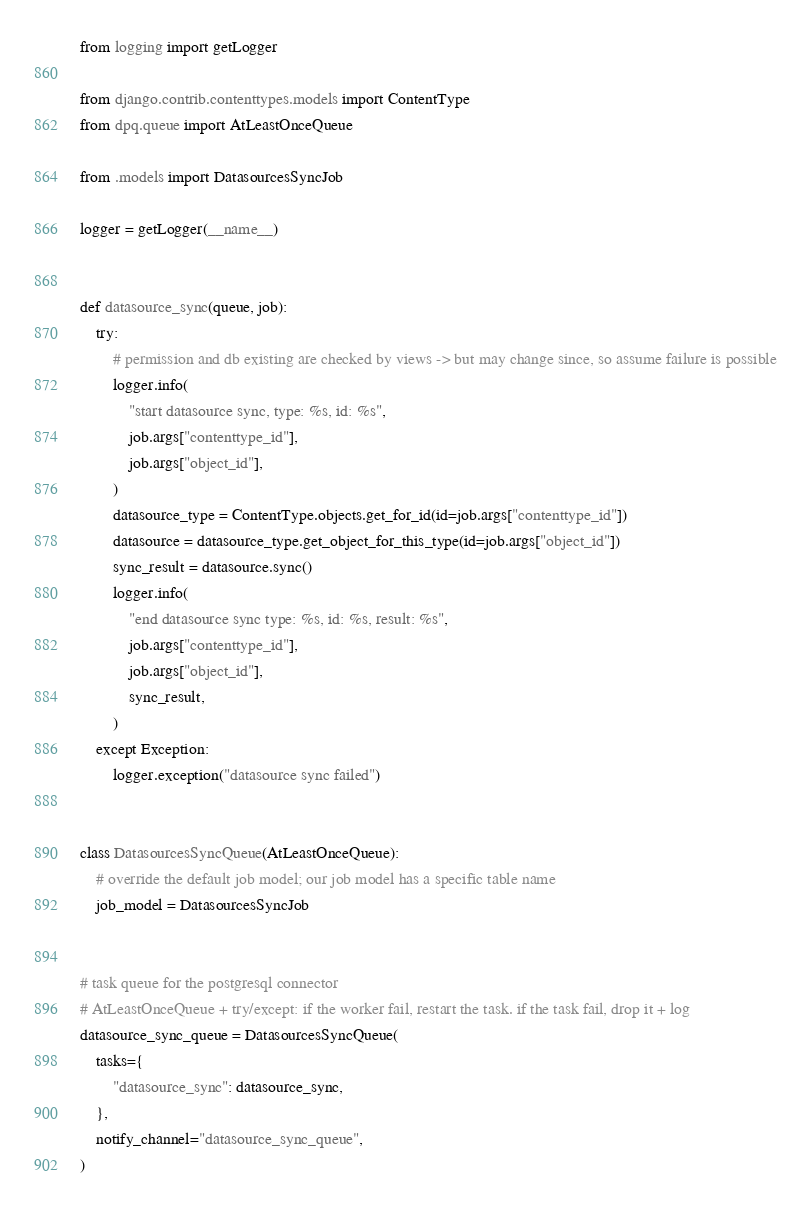<code> <loc_0><loc_0><loc_500><loc_500><_Python_>from logging import getLogger

from django.contrib.contenttypes.models import ContentType
from dpq.queue import AtLeastOnceQueue

from .models import DatasourcesSyncJob

logger = getLogger(__name__)


def datasource_sync(queue, job):
    try:
        # permission and db existing are checked by views -> but may change since, so assume failure is possible
        logger.info(
            "start datasource sync, type: %s, id: %s",
            job.args["contenttype_id"],
            job.args["object_id"],
        )
        datasource_type = ContentType.objects.get_for_id(id=job.args["contenttype_id"])
        datasource = datasource_type.get_object_for_this_type(id=job.args["object_id"])
        sync_result = datasource.sync()
        logger.info(
            "end datasource sync type: %s, id: %s, result: %s",
            job.args["contenttype_id"],
            job.args["object_id"],
            sync_result,
        )
    except Exception:
        logger.exception("datasource sync failed")


class DatasourcesSyncQueue(AtLeastOnceQueue):
    # override the default job model; our job model has a specific table name
    job_model = DatasourcesSyncJob


# task queue for the postgresql connector
# AtLeastOnceQueue + try/except: if the worker fail, restart the task. if the task fail, drop it + log
datasource_sync_queue = DatasourcesSyncQueue(
    tasks={
        "datasource_sync": datasource_sync,
    },
    notify_channel="datasource_sync_queue",
)
</code> 